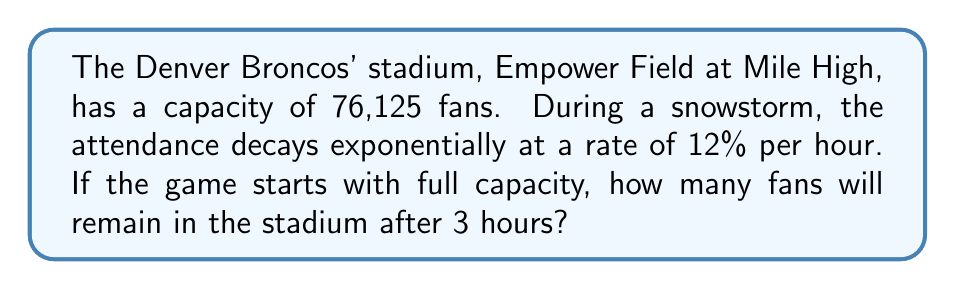Can you answer this question? Let's approach this step-by-step using the exponential decay formula:

1) The exponential decay formula is:
   $$ A(t) = A_0 \cdot (1-r)^t $$
   Where:
   $A(t)$ is the amount after time $t$
   $A_0$ is the initial amount
   $r$ is the decay rate
   $t$ is the time

2) We know:
   $A_0 = 76,125$ (initial attendance)
   $r = 0.12$ (12% decay rate)
   $t = 3$ hours

3) Plugging these values into the formula:
   $$ A(3) = 76,125 \cdot (1-0.12)^3 $$

4) Simplify inside the parentheses:
   $$ A(3) = 76,125 \cdot (0.88)^3 $$

5) Calculate the exponent:
   $$ A(3) = 76,125 \cdot 0.681472 $$

6) Multiply:
   $$ A(3) = 51,877.11 $$

7) Since we can't have a fractional number of fans, we round down to the nearest whole number.
Answer: 51,877 fans 